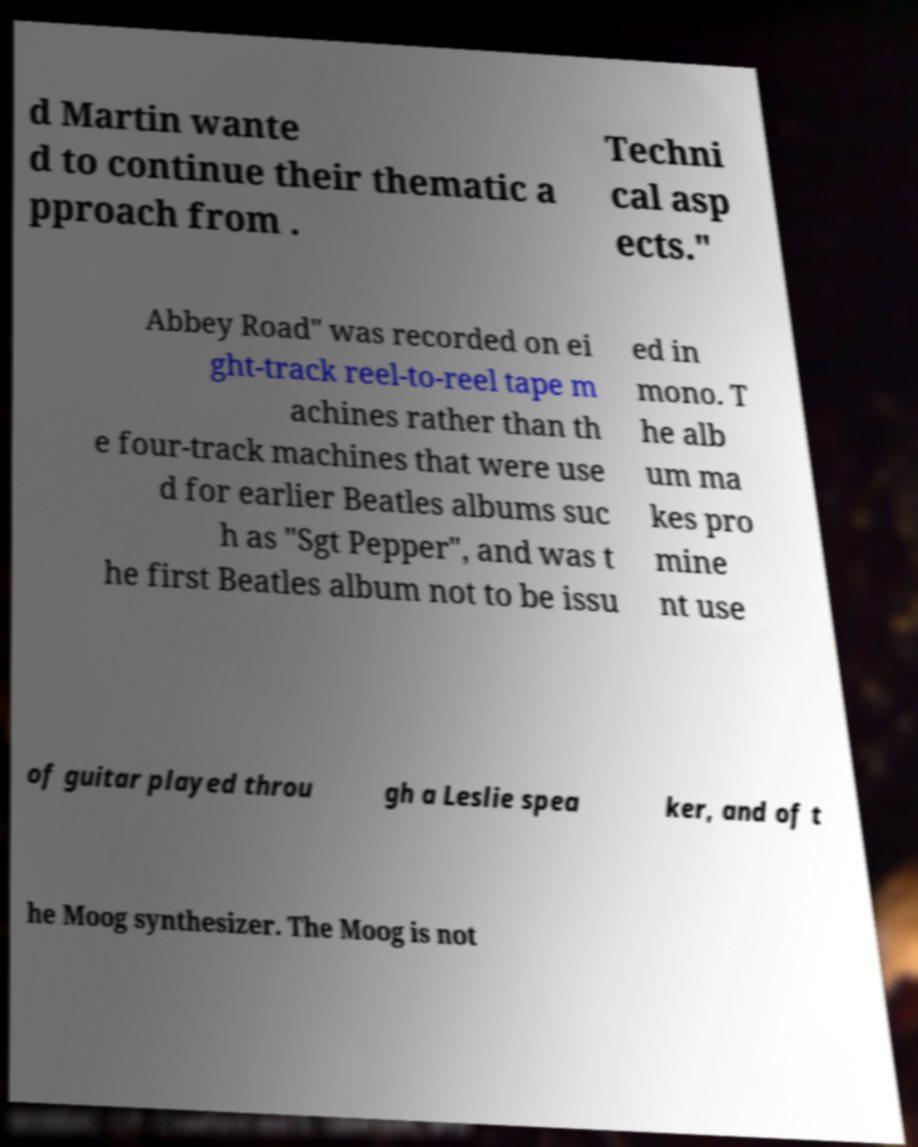I need the written content from this picture converted into text. Can you do that? d Martin wante d to continue their thematic a pproach from . Techni cal asp ects." Abbey Road" was recorded on ei ght-track reel-to-reel tape m achines rather than th e four-track machines that were use d for earlier Beatles albums suc h as "Sgt Pepper", and was t he first Beatles album not to be issu ed in mono. T he alb um ma kes pro mine nt use of guitar played throu gh a Leslie spea ker, and of t he Moog synthesizer. The Moog is not 